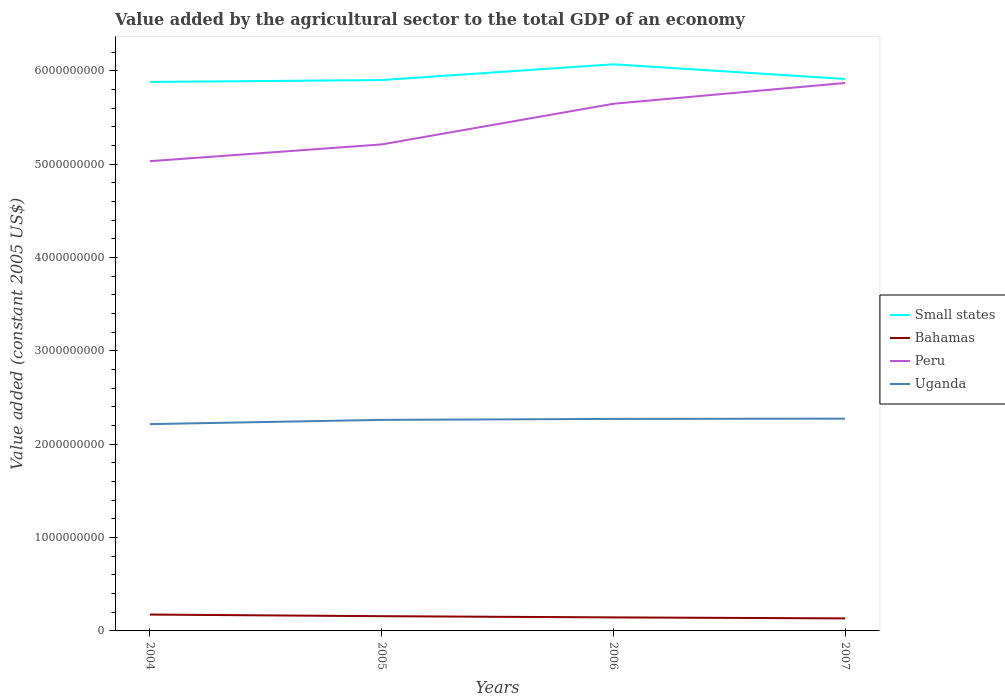Across all years, what is the maximum value added by the agricultural sector in Uganda?
Your answer should be very brief. 2.21e+09. In which year was the value added by the agricultural sector in Peru maximum?
Provide a succinct answer. 2004. What is the total value added by the agricultural sector in Uganda in the graph?
Offer a terse response. -1.04e+07. What is the difference between the highest and the second highest value added by the agricultural sector in Peru?
Keep it short and to the point. 8.37e+08. What is the difference between the highest and the lowest value added by the agricultural sector in Uganda?
Give a very brief answer. 3. Is the value added by the agricultural sector in Small states strictly greater than the value added by the agricultural sector in Bahamas over the years?
Keep it short and to the point. No. How many lines are there?
Provide a short and direct response. 4. How many years are there in the graph?
Ensure brevity in your answer.  4. Are the values on the major ticks of Y-axis written in scientific E-notation?
Offer a terse response. No. Where does the legend appear in the graph?
Provide a short and direct response. Center right. How many legend labels are there?
Provide a short and direct response. 4. How are the legend labels stacked?
Offer a terse response. Vertical. What is the title of the graph?
Keep it short and to the point. Value added by the agricultural sector to the total GDP of an economy. What is the label or title of the Y-axis?
Ensure brevity in your answer.  Value added (constant 2005 US$). What is the Value added (constant 2005 US$) of Small states in 2004?
Provide a short and direct response. 5.88e+09. What is the Value added (constant 2005 US$) of Bahamas in 2004?
Your answer should be very brief. 1.75e+08. What is the Value added (constant 2005 US$) in Peru in 2004?
Ensure brevity in your answer.  5.03e+09. What is the Value added (constant 2005 US$) in Uganda in 2004?
Your answer should be compact. 2.21e+09. What is the Value added (constant 2005 US$) in Small states in 2005?
Keep it short and to the point. 5.90e+09. What is the Value added (constant 2005 US$) of Bahamas in 2005?
Ensure brevity in your answer.  1.58e+08. What is the Value added (constant 2005 US$) of Peru in 2005?
Your response must be concise. 5.21e+09. What is the Value added (constant 2005 US$) of Uganda in 2005?
Provide a short and direct response. 2.26e+09. What is the Value added (constant 2005 US$) in Small states in 2006?
Your response must be concise. 6.07e+09. What is the Value added (constant 2005 US$) in Bahamas in 2006?
Your response must be concise. 1.45e+08. What is the Value added (constant 2005 US$) in Peru in 2006?
Make the answer very short. 5.65e+09. What is the Value added (constant 2005 US$) in Uganda in 2006?
Give a very brief answer. 2.27e+09. What is the Value added (constant 2005 US$) of Small states in 2007?
Your answer should be compact. 5.91e+09. What is the Value added (constant 2005 US$) in Bahamas in 2007?
Give a very brief answer. 1.34e+08. What is the Value added (constant 2005 US$) in Peru in 2007?
Keep it short and to the point. 5.87e+09. What is the Value added (constant 2005 US$) of Uganda in 2007?
Ensure brevity in your answer.  2.27e+09. Across all years, what is the maximum Value added (constant 2005 US$) of Small states?
Provide a short and direct response. 6.07e+09. Across all years, what is the maximum Value added (constant 2005 US$) of Bahamas?
Offer a terse response. 1.75e+08. Across all years, what is the maximum Value added (constant 2005 US$) of Peru?
Ensure brevity in your answer.  5.87e+09. Across all years, what is the maximum Value added (constant 2005 US$) in Uganda?
Your answer should be very brief. 2.27e+09. Across all years, what is the minimum Value added (constant 2005 US$) of Small states?
Give a very brief answer. 5.88e+09. Across all years, what is the minimum Value added (constant 2005 US$) of Bahamas?
Your answer should be very brief. 1.34e+08. Across all years, what is the minimum Value added (constant 2005 US$) in Peru?
Your answer should be compact. 5.03e+09. Across all years, what is the minimum Value added (constant 2005 US$) in Uganda?
Offer a very short reply. 2.21e+09. What is the total Value added (constant 2005 US$) in Small states in the graph?
Make the answer very short. 2.38e+1. What is the total Value added (constant 2005 US$) of Bahamas in the graph?
Ensure brevity in your answer.  6.12e+08. What is the total Value added (constant 2005 US$) in Peru in the graph?
Offer a terse response. 2.18e+1. What is the total Value added (constant 2005 US$) of Uganda in the graph?
Offer a terse response. 9.02e+09. What is the difference between the Value added (constant 2005 US$) in Small states in 2004 and that in 2005?
Offer a terse response. -2.01e+07. What is the difference between the Value added (constant 2005 US$) in Bahamas in 2004 and that in 2005?
Offer a very short reply. 1.74e+07. What is the difference between the Value added (constant 2005 US$) in Peru in 2004 and that in 2005?
Make the answer very short. -1.79e+08. What is the difference between the Value added (constant 2005 US$) of Uganda in 2004 and that in 2005?
Make the answer very short. -4.54e+07. What is the difference between the Value added (constant 2005 US$) of Small states in 2004 and that in 2006?
Your answer should be very brief. -1.89e+08. What is the difference between the Value added (constant 2005 US$) in Bahamas in 2004 and that in 2006?
Offer a terse response. 3.03e+07. What is the difference between the Value added (constant 2005 US$) of Peru in 2004 and that in 2006?
Your answer should be compact. -6.15e+08. What is the difference between the Value added (constant 2005 US$) of Uganda in 2004 and that in 2006?
Your response must be concise. -5.58e+07. What is the difference between the Value added (constant 2005 US$) of Small states in 2004 and that in 2007?
Your answer should be compact. -3.19e+07. What is the difference between the Value added (constant 2005 US$) in Bahamas in 2004 and that in 2007?
Make the answer very short. 4.09e+07. What is the difference between the Value added (constant 2005 US$) in Peru in 2004 and that in 2007?
Make the answer very short. -8.37e+08. What is the difference between the Value added (constant 2005 US$) of Uganda in 2004 and that in 2007?
Keep it short and to the point. -5.85e+07. What is the difference between the Value added (constant 2005 US$) of Small states in 2005 and that in 2006?
Provide a short and direct response. -1.69e+08. What is the difference between the Value added (constant 2005 US$) in Bahamas in 2005 and that in 2006?
Keep it short and to the point. 1.29e+07. What is the difference between the Value added (constant 2005 US$) of Peru in 2005 and that in 2006?
Your answer should be very brief. -4.36e+08. What is the difference between the Value added (constant 2005 US$) in Uganda in 2005 and that in 2006?
Keep it short and to the point. -1.04e+07. What is the difference between the Value added (constant 2005 US$) in Small states in 2005 and that in 2007?
Your answer should be very brief. -1.18e+07. What is the difference between the Value added (constant 2005 US$) of Bahamas in 2005 and that in 2007?
Keep it short and to the point. 2.35e+07. What is the difference between the Value added (constant 2005 US$) in Peru in 2005 and that in 2007?
Make the answer very short. -6.58e+08. What is the difference between the Value added (constant 2005 US$) of Uganda in 2005 and that in 2007?
Offer a very short reply. -1.31e+07. What is the difference between the Value added (constant 2005 US$) in Small states in 2006 and that in 2007?
Provide a succinct answer. 1.57e+08. What is the difference between the Value added (constant 2005 US$) of Bahamas in 2006 and that in 2007?
Ensure brevity in your answer.  1.06e+07. What is the difference between the Value added (constant 2005 US$) in Peru in 2006 and that in 2007?
Provide a succinct answer. -2.23e+08. What is the difference between the Value added (constant 2005 US$) in Uganda in 2006 and that in 2007?
Your response must be concise. -2.71e+06. What is the difference between the Value added (constant 2005 US$) of Small states in 2004 and the Value added (constant 2005 US$) of Bahamas in 2005?
Your response must be concise. 5.72e+09. What is the difference between the Value added (constant 2005 US$) of Small states in 2004 and the Value added (constant 2005 US$) of Peru in 2005?
Your response must be concise. 6.69e+08. What is the difference between the Value added (constant 2005 US$) of Small states in 2004 and the Value added (constant 2005 US$) of Uganda in 2005?
Your response must be concise. 3.62e+09. What is the difference between the Value added (constant 2005 US$) in Bahamas in 2004 and the Value added (constant 2005 US$) in Peru in 2005?
Your response must be concise. -5.04e+09. What is the difference between the Value added (constant 2005 US$) in Bahamas in 2004 and the Value added (constant 2005 US$) in Uganda in 2005?
Offer a terse response. -2.09e+09. What is the difference between the Value added (constant 2005 US$) of Peru in 2004 and the Value added (constant 2005 US$) of Uganda in 2005?
Give a very brief answer. 2.77e+09. What is the difference between the Value added (constant 2005 US$) of Small states in 2004 and the Value added (constant 2005 US$) of Bahamas in 2006?
Provide a succinct answer. 5.73e+09. What is the difference between the Value added (constant 2005 US$) in Small states in 2004 and the Value added (constant 2005 US$) in Peru in 2006?
Give a very brief answer. 2.34e+08. What is the difference between the Value added (constant 2005 US$) in Small states in 2004 and the Value added (constant 2005 US$) in Uganda in 2006?
Offer a terse response. 3.61e+09. What is the difference between the Value added (constant 2005 US$) in Bahamas in 2004 and the Value added (constant 2005 US$) in Peru in 2006?
Offer a very short reply. -5.47e+09. What is the difference between the Value added (constant 2005 US$) in Bahamas in 2004 and the Value added (constant 2005 US$) in Uganda in 2006?
Your answer should be very brief. -2.10e+09. What is the difference between the Value added (constant 2005 US$) in Peru in 2004 and the Value added (constant 2005 US$) in Uganda in 2006?
Make the answer very short. 2.76e+09. What is the difference between the Value added (constant 2005 US$) in Small states in 2004 and the Value added (constant 2005 US$) in Bahamas in 2007?
Provide a short and direct response. 5.75e+09. What is the difference between the Value added (constant 2005 US$) in Small states in 2004 and the Value added (constant 2005 US$) in Peru in 2007?
Give a very brief answer. 1.11e+07. What is the difference between the Value added (constant 2005 US$) in Small states in 2004 and the Value added (constant 2005 US$) in Uganda in 2007?
Make the answer very short. 3.61e+09. What is the difference between the Value added (constant 2005 US$) of Bahamas in 2004 and the Value added (constant 2005 US$) of Peru in 2007?
Make the answer very short. -5.69e+09. What is the difference between the Value added (constant 2005 US$) of Bahamas in 2004 and the Value added (constant 2005 US$) of Uganda in 2007?
Make the answer very short. -2.10e+09. What is the difference between the Value added (constant 2005 US$) in Peru in 2004 and the Value added (constant 2005 US$) in Uganda in 2007?
Your answer should be compact. 2.76e+09. What is the difference between the Value added (constant 2005 US$) of Small states in 2005 and the Value added (constant 2005 US$) of Bahamas in 2006?
Offer a terse response. 5.75e+09. What is the difference between the Value added (constant 2005 US$) in Small states in 2005 and the Value added (constant 2005 US$) in Peru in 2006?
Ensure brevity in your answer.  2.54e+08. What is the difference between the Value added (constant 2005 US$) of Small states in 2005 and the Value added (constant 2005 US$) of Uganda in 2006?
Offer a very short reply. 3.63e+09. What is the difference between the Value added (constant 2005 US$) in Bahamas in 2005 and the Value added (constant 2005 US$) in Peru in 2006?
Provide a succinct answer. -5.49e+09. What is the difference between the Value added (constant 2005 US$) in Bahamas in 2005 and the Value added (constant 2005 US$) in Uganda in 2006?
Give a very brief answer. -2.11e+09. What is the difference between the Value added (constant 2005 US$) in Peru in 2005 and the Value added (constant 2005 US$) in Uganda in 2006?
Offer a very short reply. 2.94e+09. What is the difference between the Value added (constant 2005 US$) in Small states in 2005 and the Value added (constant 2005 US$) in Bahamas in 2007?
Provide a short and direct response. 5.77e+09. What is the difference between the Value added (constant 2005 US$) in Small states in 2005 and the Value added (constant 2005 US$) in Peru in 2007?
Provide a short and direct response. 3.12e+07. What is the difference between the Value added (constant 2005 US$) of Small states in 2005 and the Value added (constant 2005 US$) of Uganda in 2007?
Offer a terse response. 3.63e+09. What is the difference between the Value added (constant 2005 US$) of Bahamas in 2005 and the Value added (constant 2005 US$) of Peru in 2007?
Make the answer very short. -5.71e+09. What is the difference between the Value added (constant 2005 US$) of Bahamas in 2005 and the Value added (constant 2005 US$) of Uganda in 2007?
Give a very brief answer. -2.12e+09. What is the difference between the Value added (constant 2005 US$) in Peru in 2005 and the Value added (constant 2005 US$) in Uganda in 2007?
Make the answer very short. 2.94e+09. What is the difference between the Value added (constant 2005 US$) in Small states in 2006 and the Value added (constant 2005 US$) in Bahamas in 2007?
Make the answer very short. 5.93e+09. What is the difference between the Value added (constant 2005 US$) of Small states in 2006 and the Value added (constant 2005 US$) of Peru in 2007?
Your answer should be compact. 2.00e+08. What is the difference between the Value added (constant 2005 US$) in Small states in 2006 and the Value added (constant 2005 US$) in Uganda in 2007?
Offer a terse response. 3.80e+09. What is the difference between the Value added (constant 2005 US$) in Bahamas in 2006 and the Value added (constant 2005 US$) in Peru in 2007?
Provide a short and direct response. -5.72e+09. What is the difference between the Value added (constant 2005 US$) of Bahamas in 2006 and the Value added (constant 2005 US$) of Uganda in 2007?
Your response must be concise. -2.13e+09. What is the difference between the Value added (constant 2005 US$) of Peru in 2006 and the Value added (constant 2005 US$) of Uganda in 2007?
Keep it short and to the point. 3.37e+09. What is the average Value added (constant 2005 US$) of Small states per year?
Offer a terse response. 5.94e+09. What is the average Value added (constant 2005 US$) of Bahamas per year?
Make the answer very short. 1.53e+08. What is the average Value added (constant 2005 US$) in Peru per year?
Provide a succinct answer. 5.44e+09. What is the average Value added (constant 2005 US$) of Uganda per year?
Your answer should be compact. 2.25e+09. In the year 2004, what is the difference between the Value added (constant 2005 US$) in Small states and Value added (constant 2005 US$) in Bahamas?
Offer a terse response. 5.70e+09. In the year 2004, what is the difference between the Value added (constant 2005 US$) in Small states and Value added (constant 2005 US$) in Peru?
Offer a terse response. 8.48e+08. In the year 2004, what is the difference between the Value added (constant 2005 US$) in Small states and Value added (constant 2005 US$) in Uganda?
Your answer should be very brief. 3.66e+09. In the year 2004, what is the difference between the Value added (constant 2005 US$) in Bahamas and Value added (constant 2005 US$) in Peru?
Make the answer very short. -4.86e+09. In the year 2004, what is the difference between the Value added (constant 2005 US$) in Bahamas and Value added (constant 2005 US$) in Uganda?
Your answer should be compact. -2.04e+09. In the year 2004, what is the difference between the Value added (constant 2005 US$) in Peru and Value added (constant 2005 US$) in Uganda?
Ensure brevity in your answer.  2.82e+09. In the year 2005, what is the difference between the Value added (constant 2005 US$) of Small states and Value added (constant 2005 US$) of Bahamas?
Your answer should be compact. 5.74e+09. In the year 2005, what is the difference between the Value added (constant 2005 US$) of Small states and Value added (constant 2005 US$) of Peru?
Offer a very short reply. 6.89e+08. In the year 2005, what is the difference between the Value added (constant 2005 US$) of Small states and Value added (constant 2005 US$) of Uganda?
Your answer should be compact. 3.64e+09. In the year 2005, what is the difference between the Value added (constant 2005 US$) in Bahamas and Value added (constant 2005 US$) in Peru?
Provide a short and direct response. -5.05e+09. In the year 2005, what is the difference between the Value added (constant 2005 US$) of Bahamas and Value added (constant 2005 US$) of Uganda?
Offer a terse response. -2.10e+09. In the year 2005, what is the difference between the Value added (constant 2005 US$) in Peru and Value added (constant 2005 US$) in Uganda?
Your answer should be very brief. 2.95e+09. In the year 2006, what is the difference between the Value added (constant 2005 US$) in Small states and Value added (constant 2005 US$) in Bahamas?
Provide a succinct answer. 5.92e+09. In the year 2006, what is the difference between the Value added (constant 2005 US$) in Small states and Value added (constant 2005 US$) in Peru?
Provide a short and direct response. 4.23e+08. In the year 2006, what is the difference between the Value added (constant 2005 US$) in Small states and Value added (constant 2005 US$) in Uganda?
Keep it short and to the point. 3.80e+09. In the year 2006, what is the difference between the Value added (constant 2005 US$) in Bahamas and Value added (constant 2005 US$) in Peru?
Offer a very short reply. -5.50e+09. In the year 2006, what is the difference between the Value added (constant 2005 US$) of Bahamas and Value added (constant 2005 US$) of Uganda?
Ensure brevity in your answer.  -2.13e+09. In the year 2006, what is the difference between the Value added (constant 2005 US$) in Peru and Value added (constant 2005 US$) in Uganda?
Keep it short and to the point. 3.38e+09. In the year 2007, what is the difference between the Value added (constant 2005 US$) in Small states and Value added (constant 2005 US$) in Bahamas?
Provide a short and direct response. 5.78e+09. In the year 2007, what is the difference between the Value added (constant 2005 US$) in Small states and Value added (constant 2005 US$) in Peru?
Give a very brief answer. 4.30e+07. In the year 2007, what is the difference between the Value added (constant 2005 US$) in Small states and Value added (constant 2005 US$) in Uganda?
Provide a short and direct response. 3.64e+09. In the year 2007, what is the difference between the Value added (constant 2005 US$) in Bahamas and Value added (constant 2005 US$) in Peru?
Your answer should be compact. -5.73e+09. In the year 2007, what is the difference between the Value added (constant 2005 US$) in Bahamas and Value added (constant 2005 US$) in Uganda?
Offer a terse response. -2.14e+09. In the year 2007, what is the difference between the Value added (constant 2005 US$) of Peru and Value added (constant 2005 US$) of Uganda?
Give a very brief answer. 3.59e+09. What is the ratio of the Value added (constant 2005 US$) in Small states in 2004 to that in 2005?
Provide a short and direct response. 1. What is the ratio of the Value added (constant 2005 US$) in Bahamas in 2004 to that in 2005?
Make the answer very short. 1.11. What is the ratio of the Value added (constant 2005 US$) of Peru in 2004 to that in 2005?
Your answer should be very brief. 0.97. What is the ratio of the Value added (constant 2005 US$) in Uganda in 2004 to that in 2005?
Your response must be concise. 0.98. What is the ratio of the Value added (constant 2005 US$) in Small states in 2004 to that in 2006?
Offer a terse response. 0.97. What is the ratio of the Value added (constant 2005 US$) in Bahamas in 2004 to that in 2006?
Give a very brief answer. 1.21. What is the ratio of the Value added (constant 2005 US$) of Peru in 2004 to that in 2006?
Provide a succinct answer. 0.89. What is the ratio of the Value added (constant 2005 US$) in Uganda in 2004 to that in 2006?
Offer a very short reply. 0.98. What is the ratio of the Value added (constant 2005 US$) in Small states in 2004 to that in 2007?
Ensure brevity in your answer.  0.99. What is the ratio of the Value added (constant 2005 US$) of Bahamas in 2004 to that in 2007?
Provide a short and direct response. 1.3. What is the ratio of the Value added (constant 2005 US$) of Peru in 2004 to that in 2007?
Provide a short and direct response. 0.86. What is the ratio of the Value added (constant 2005 US$) in Uganda in 2004 to that in 2007?
Provide a succinct answer. 0.97. What is the ratio of the Value added (constant 2005 US$) in Small states in 2005 to that in 2006?
Keep it short and to the point. 0.97. What is the ratio of the Value added (constant 2005 US$) in Bahamas in 2005 to that in 2006?
Your answer should be compact. 1.09. What is the ratio of the Value added (constant 2005 US$) in Peru in 2005 to that in 2006?
Make the answer very short. 0.92. What is the ratio of the Value added (constant 2005 US$) of Bahamas in 2005 to that in 2007?
Your answer should be compact. 1.18. What is the ratio of the Value added (constant 2005 US$) of Peru in 2005 to that in 2007?
Provide a short and direct response. 0.89. What is the ratio of the Value added (constant 2005 US$) of Small states in 2006 to that in 2007?
Give a very brief answer. 1.03. What is the ratio of the Value added (constant 2005 US$) in Bahamas in 2006 to that in 2007?
Your answer should be very brief. 1.08. What is the ratio of the Value added (constant 2005 US$) of Peru in 2006 to that in 2007?
Your answer should be very brief. 0.96. What is the difference between the highest and the second highest Value added (constant 2005 US$) in Small states?
Your answer should be very brief. 1.57e+08. What is the difference between the highest and the second highest Value added (constant 2005 US$) in Bahamas?
Offer a terse response. 1.74e+07. What is the difference between the highest and the second highest Value added (constant 2005 US$) of Peru?
Keep it short and to the point. 2.23e+08. What is the difference between the highest and the second highest Value added (constant 2005 US$) of Uganda?
Ensure brevity in your answer.  2.71e+06. What is the difference between the highest and the lowest Value added (constant 2005 US$) in Small states?
Keep it short and to the point. 1.89e+08. What is the difference between the highest and the lowest Value added (constant 2005 US$) in Bahamas?
Your answer should be very brief. 4.09e+07. What is the difference between the highest and the lowest Value added (constant 2005 US$) in Peru?
Provide a succinct answer. 8.37e+08. What is the difference between the highest and the lowest Value added (constant 2005 US$) in Uganda?
Offer a terse response. 5.85e+07. 